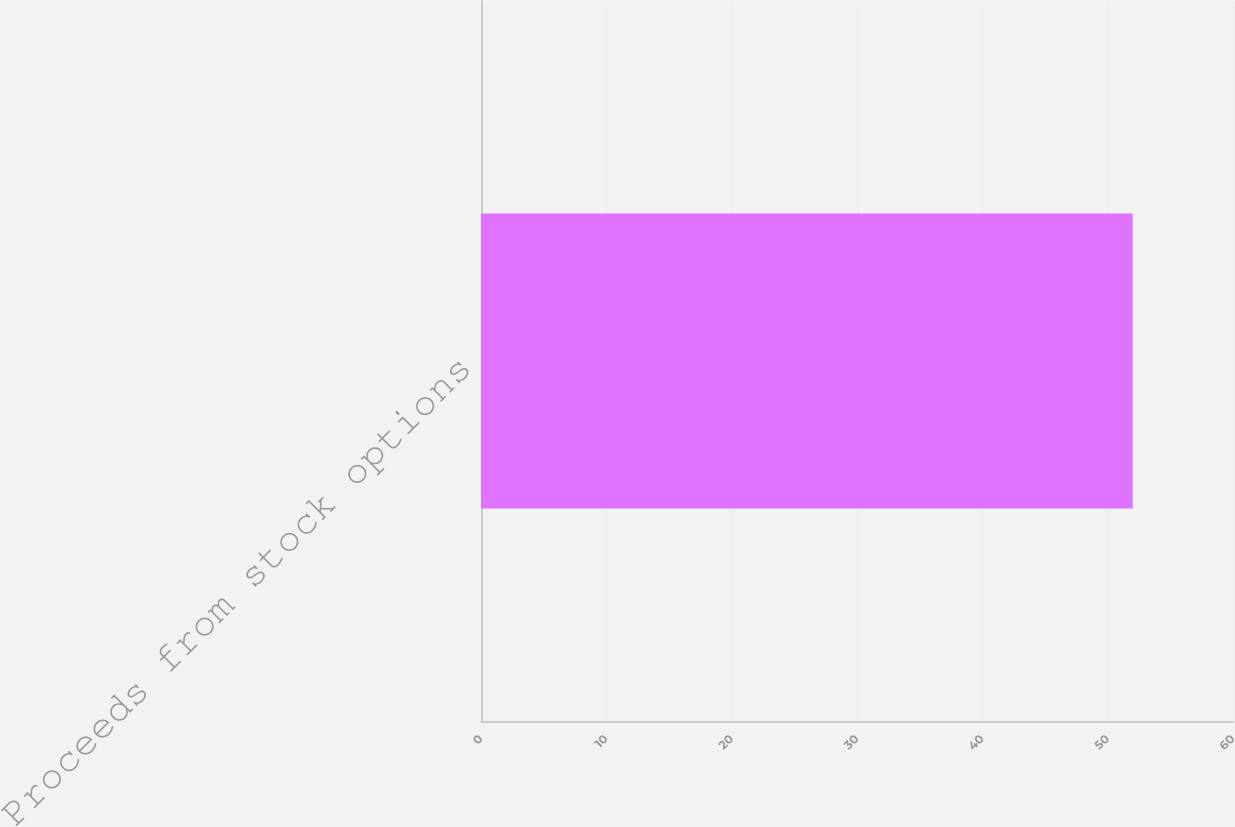<chart> <loc_0><loc_0><loc_500><loc_500><bar_chart><fcel>Proceeds from stock options<nl><fcel>52<nl></chart> 